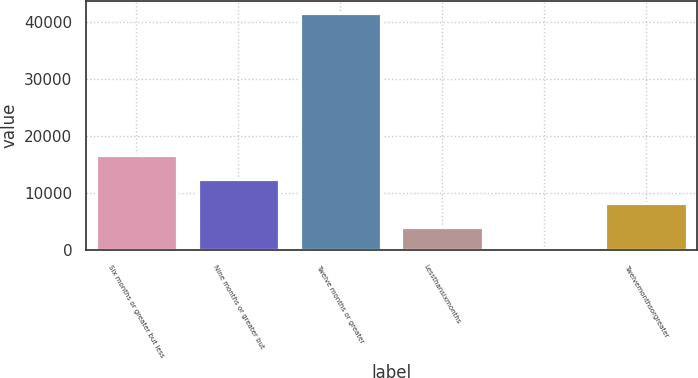<chart> <loc_0><loc_0><loc_500><loc_500><bar_chart><fcel>Six months or greater but less<fcel>Nine months or greater but<fcel>Twelve months or greater<fcel>Lessthansixmonths<fcel>Unnamed: 4<fcel>Twelvemonthsorgreater<nl><fcel>16692<fcel>12520.5<fcel>41721<fcel>4177.5<fcel>6<fcel>8349<nl></chart> 